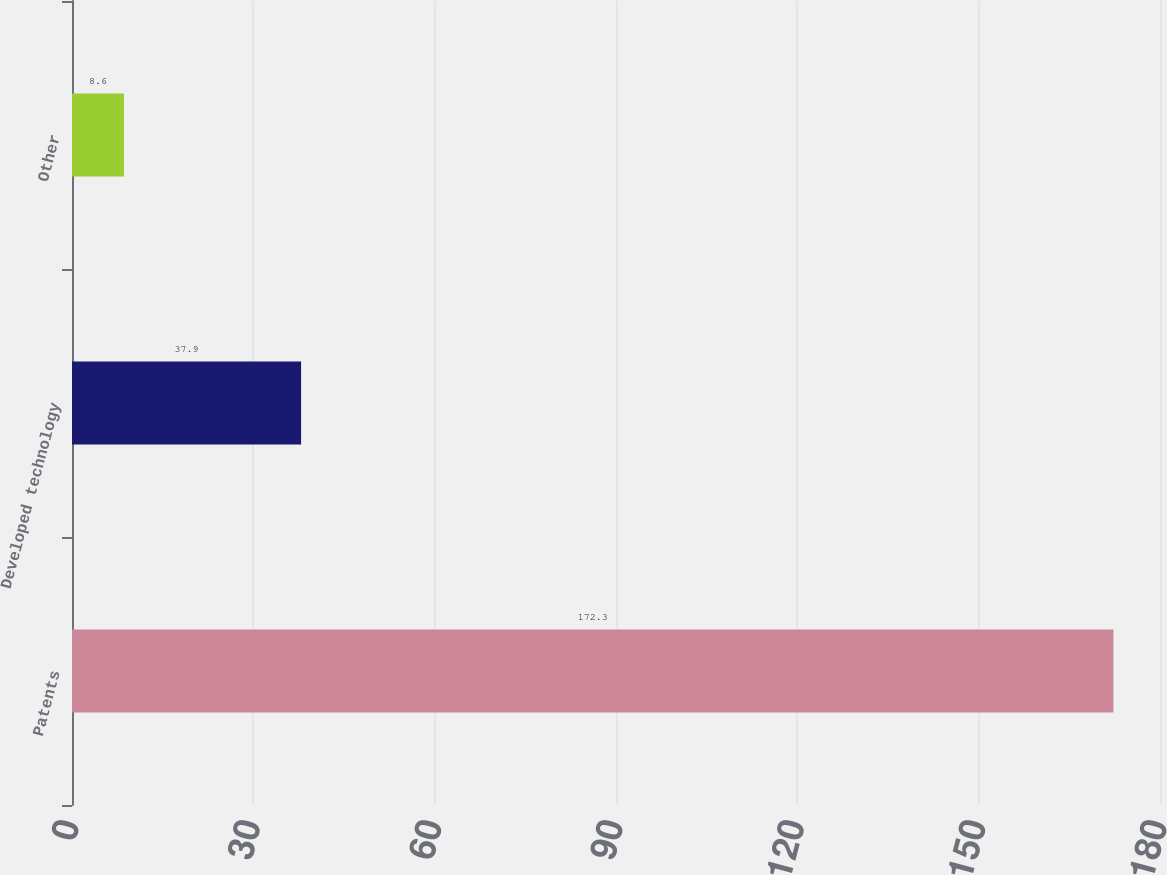Convert chart. <chart><loc_0><loc_0><loc_500><loc_500><bar_chart><fcel>Patents<fcel>Developed technology<fcel>Other<nl><fcel>172.3<fcel>37.9<fcel>8.6<nl></chart> 